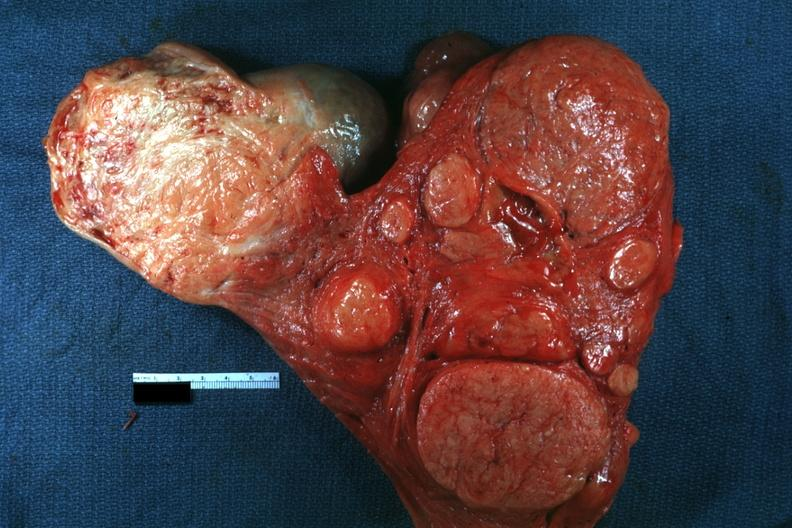s immunostain for growth hormone present?
Answer the question using a single word or phrase. No 